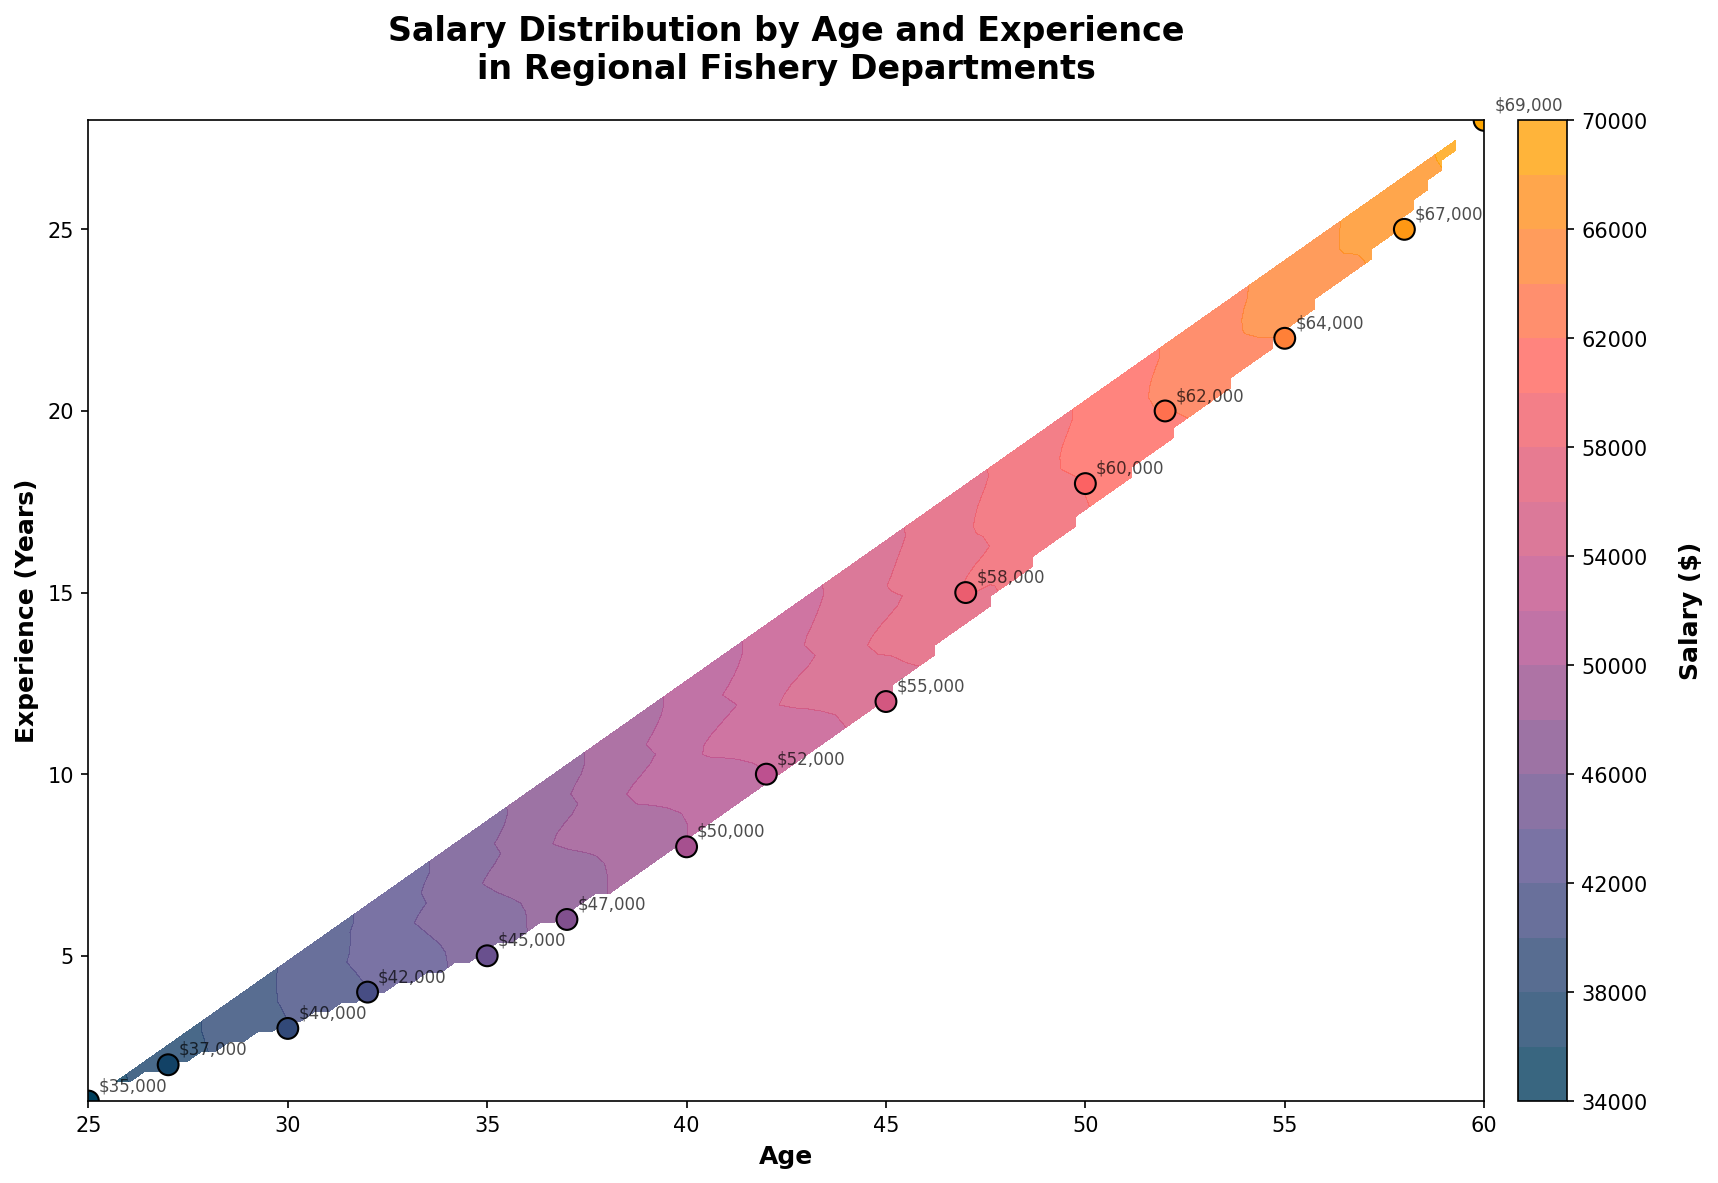What is the title of the plot? The title of the plot is located at the top of the figure. It should be clear and prominent, usually in a bold font to highlight the main focus of the plot. Here, it reads "Salary Distribution by Age and Experience in Regional Fishery Departments".
Answer: Salary Distribution by Age and Experience in Regional Fishery Departments How many data points are there in the plot? Each data point corresponds to a pair of age and experience values plotted on the scatter plot. Counting all the scatter points shown within the contour plot, we can observe there are 15 individual points.
Answer: 15 What does the colorbar represent? The colorbar is usually placed beside the main plot and is essential for interpreting the colors within the contour plot. The colorbar here has a label indicating it shows salary values in dollars. Therefore, it helps to understand the gradient of salaries across different combinations of age and experience.
Answer: Salary in dollars What age range is covered in the plot? The x-axis, labeled as "Age", shows the range of ages included in the plot. Observing the minimum and maximum tick values on this axis, we see that the plot covers ages from 25 to 60, reflecting the age distribution among the employees.
Answer: 25 to 60 Which combination of age and experience results in the highest salary? By observing the data points and annotations on the plot, we can identify the maximum salary. The highest salary annotation is $69,000, which corresponds to an age of 60 and 28 years of experience. The scatter point at this coordinate confirms this combination.
Answer: Age 60 and 28 years of experience What is the average salary for employees aged below 40? To calculate the average salary for employees aged below 40, identify the data points corresponding to ages less than 40 (25, 27, 30, 32, and 35), sum their salaries (35000+37000+40000+42000+45000) which equals 199000, and divide by the number of these employees (5).
Answer: $39,800 How does salary change with increasing experience for employees aged 45? Find the data points for an age of 45, then compare the corresponding salary values as experience increases. In this plot, there is only one data point at age 45 with 12 years of experience and a salary of $55,000. Therefore, for this age, no variation can be noted with increasing experience.
Answer: $55,000 At what age and experience is the salary first observed to be $50,000? Looking at the annotations and data points, the first time we see a $50,000 salary is for an employee aged 40 with 8 years of experience. The corresponding scatter point confirms this figure.
Answer: Age 40 and 8 years of experience Does a trend of increasing salary with both age and experience hold across the plot? We can observe the general upward trend in the contour plot where higher age and experience values tend to correspond with higher salary values. The contour lines, annotations, and scatter points collectively support this observation.
Answer: Yes How does the salary distribution vary for employees with 10 to 20 years of experience? To understand this, observe the contour levels as they cross the experience values from 10 to 20 years. The salary values increase steadily from $52,000 at 10 years to $62,000 at 20 years, showing a consistent rise. The associated scatter points within this experience range also indicate this increasing trend.
Answer: Salaries increase from $52,000 to $62,000 